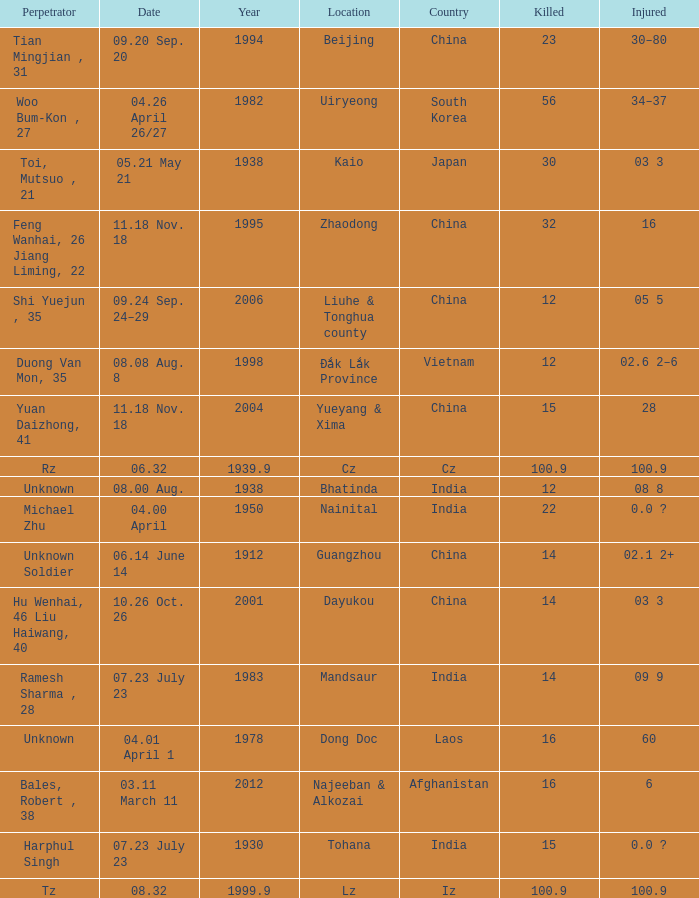What is Injured, when Country is "Afghanistan"? 6.0. Give me the full table as a dictionary. {'header': ['Perpetrator', 'Date', 'Year', 'Location', 'Country', 'Killed', 'Injured'], 'rows': [['Tian Mingjian , 31', '09.20 Sep. 20', '1994', 'Beijing', 'China', '23', '30–80'], ['Woo Bum-Kon , 27', '04.26 April 26/27', '1982', 'Uiryeong', 'South Korea', '56', '34–37'], ['Toi, Mutsuo , 21', '05.21 May 21', '1938', 'Kaio', 'Japan', '30', '03 3'], ['Feng Wanhai, 26 Jiang Liming, 22', '11.18 Nov. 18', '1995', 'Zhaodong', 'China', '32', '16'], ['Shi Yuejun , 35', '09.24 Sep. 24–29', '2006', 'Liuhe & Tonghua county', 'China', '12', '05 5'], ['Duong Van Mon, 35', '08.08 Aug. 8', '1998', 'Đắk Lắk Province', 'Vietnam', '12', '02.6 2–6'], ['Yuan Daizhong, 41', '11.18 Nov. 18', '2004', 'Yueyang & Xima', 'China', '15', '28'], ['Rz', '06.32', '1939.9', 'Cz', 'Cz', '100.9', '100.9'], ['Unknown', '08.00 Aug.', '1938', 'Bhatinda', 'India', '12', '08 8'], ['Michael Zhu', '04.00 April', '1950', 'Nainital', 'India', '22', '0.0 ?'], ['Unknown Soldier', '06.14 June 14', '1912', 'Guangzhou', 'China', '14', '02.1 2+'], ['Hu Wenhai, 46 Liu Haiwang, 40', '10.26 Oct. 26', '2001', 'Dayukou', 'China', '14', '03 3'], ['Ramesh Sharma , 28', '07.23 July 23', '1983', 'Mandsaur', 'India', '14', '09 9'], ['Unknown', '04.01 April 1', '1978', 'Dong Doc', 'Laos', '16', '60'], ['Bales, Robert , 38', '03.11 March 11', '2012', 'Najeeban & Alkozai', 'Afghanistan', '16', '6'], ['Harphul Singh', '07.23 July 23', '1930', 'Tohana', 'India', '15', '0.0 ?'], ['Tz', '08.32', '1999.9', 'Lz', 'Iz', '100.9', '100.9']]} 